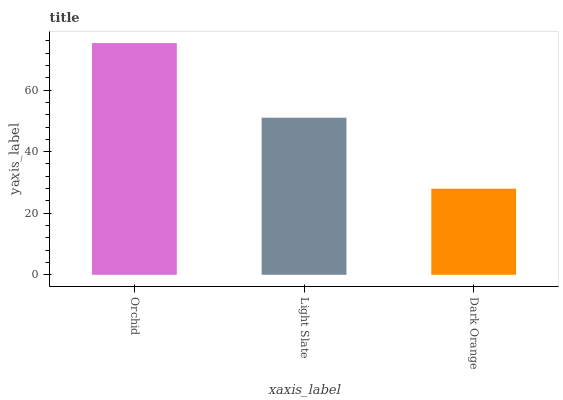Is Light Slate the minimum?
Answer yes or no. No. Is Light Slate the maximum?
Answer yes or no. No. Is Orchid greater than Light Slate?
Answer yes or no. Yes. Is Light Slate less than Orchid?
Answer yes or no. Yes. Is Light Slate greater than Orchid?
Answer yes or no. No. Is Orchid less than Light Slate?
Answer yes or no. No. Is Light Slate the high median?
Answer yes or no. Yes. Is Light Slate the low median?
Answer yes or no. Yes. Is Orchid the high median?
Answer yes or no. No. Is Dark Orange the low median?
Answer yes or no. No. 